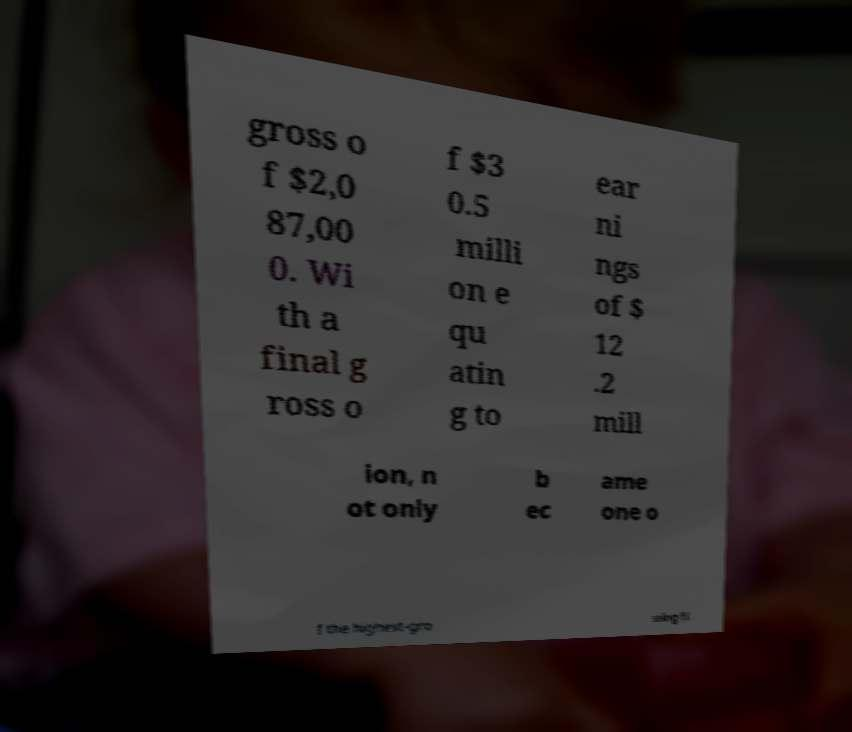Can you accurately transcribe the text from the provided image for me? gross o f $2,0 87,00 0. Wi th a final g ross o f $3 0.5 milli on e qu atin g to ear ni ngs of $ 12 .2 mill ion, n ot only b ec ame one o f the highest-gro ssing fi 